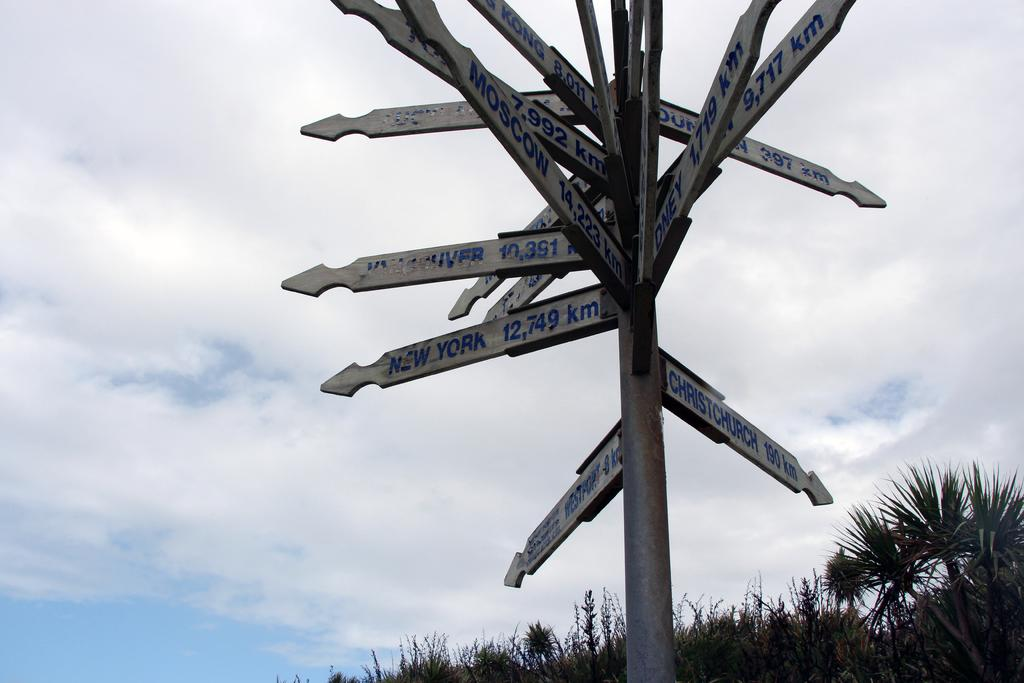<image>
Give a short and clear explanation of the subsequent image. A post rises into the sky with signposts pointing to Moscow, New York, Christchurch, and many other major cities. 